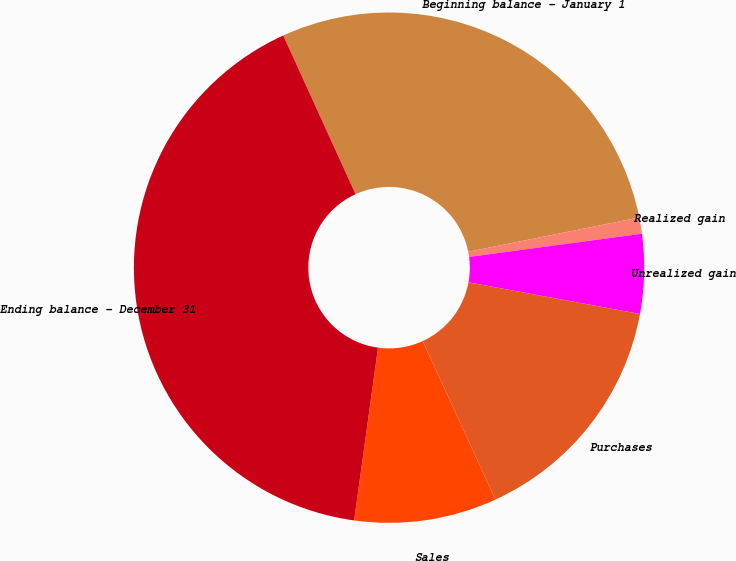Convert chart to OTSL. <chart><loc_0><loc_0><loc_500><loc_500><pie_chart><fcel>Beginning balance - January 1<fcel>Realized gain<fcel>Unrealized gain<fcel>Purchases<fcel>Sales<fcel>Ending balance - December 31<nl><fcel>28.65%<fcel>1.03%<fcel>5.03%<fcel>15.25%<fcel>9.03%<fcel>41.01%<nl></chart> 